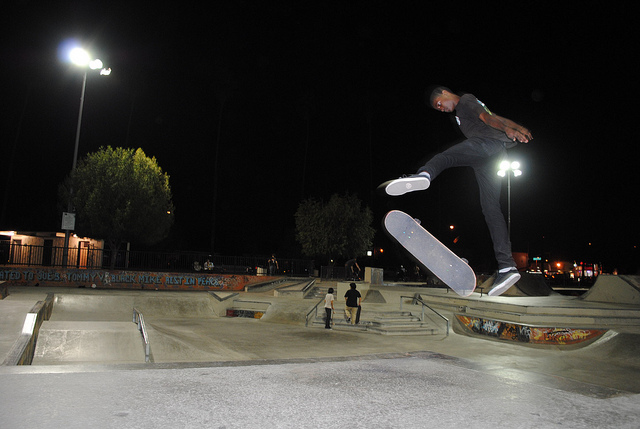Identify and read out the text in this image. TOMMY 